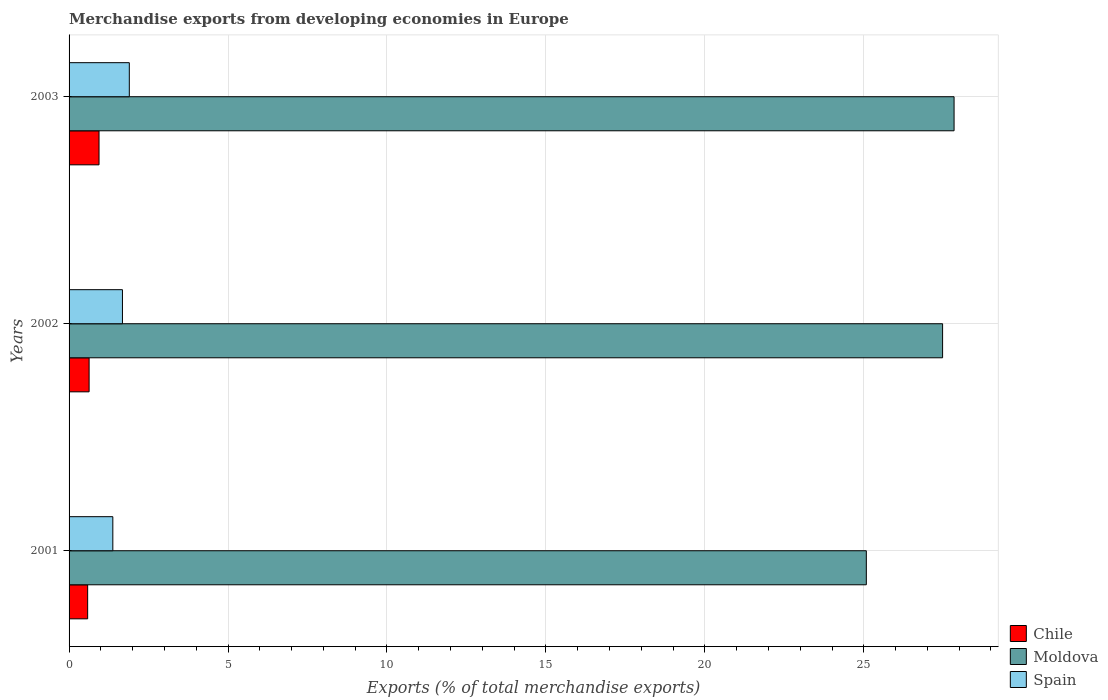How many different coloured bars are there?
Your answer should be compact. 3. How many groups of bars are there?
Offer a terse response. 3. Are the number of bars per tick equal to the number of legend labels?
Your answer should be compact. Yes. How many bars are there on the 3rd tick from the top?
Your answer should be compact. 3. How many bars are there on the 3rd tick from the bottom?
Your answer should be compact. 3. What is the label of the 1st group of bars from the top?
Your answer should be compact. 2003. What is the percentage of total merchandise exports in Chile in 2001?
Provide a succinct answer. 0.58. Across all years, what is the maximum percentage of total merchandise exports in Spain?
Offer a terse response. 1.9. Across all years, what is the minimum percentage of total merchandise exports in Chile?
Ensure brevity in your answer.  0.58. What is the total percentage of total merchandise exports in Spain in the graph?
Make the answer very short. 4.95. What is the difference between the percentage of total merchandise exports in Chile in 2001 and that in 2003?
Keep it short and to the point. -0.36. What is the difference between the percentage of total merchandise exports in Chile in 2001 and the percentage of total merchandise exports in Spain in 2003?
Offer a very short reply. -1.31. What is the average percentage of total merchandise exports in Chile per year?
Your answer should be very brief. 0.72. In the year 2001, what is the difference between the percentage of total merchandise exports in Spain and percentage of total merchandise exports in Chile?
Provide a succinct answer. 0.79. What is the ratio of the percentage of total merchandise exports in Chile in 2001 to that in 2002?
Offer a terse response. 0.93. Is the difference between the percentage of total merchandise exports in Spain in 2001 and 2002 greater than the difference between the percentage of total merchandise exports in Chile in 2001 and 2002?
Your response must be concise. No. What is the difference between the highest and the second highest percentage of total merchandise exports in Moldova?
Ensure brevity in your answer.  0.36. What is the difference between the highest and the lowest percentage of total merchandise exports in Chile?
Provide a succinct answer. 0.36. In how many years, is the percentage of total merchandise exports in Moldova greater than the average percentage of total merchandise exports in Moldova taken over all years?
Offer a very short reply. 2. Is the sum of the percentage of total merchandise exports in Chile in 2001 and 2002 greater than the maximum percentage of total merchandise exports in Spain across all years?
Provide a short and direct response. No. What does the 3rd bar from the bottom in 2002 represents?
Offer a very short reply. Spain. Is it the case that in every year, the sum of the percentage of total merchandise exports in Chile and percentage of total merchandise exports in Moldova is greater than the percentage of total merchandise exports in Spain?
Ensure brevity in your answer.  Yes. Are all the bars in the graph horizontal?
Offer a very short reply. Yes. How many years are there in the graph?
Your response must be concise. 3. What is the difference between two consecutive major ticks on the X-axis?
Provide a succinct answer. 5. Are the values on the major ticks of X-axis written in scientific E-notation?
Your answer should be very brief. No. Does the graph contain grids?
Your answer should be compact. Yes. How many legend labels are there?
Your answer should be compact. 3. What is the title of the graph?
Your answer should be compact. Merchandise exports from developing economies in Europe. What is the label or title of the X-axis?
Give a very brief answer. Exports (% of total merchandise exports). What is the label or title of the Y-axis?
Give a very brief answer. Years. What is the Exports (% of total merchandise exports) in Chile in 2001?
Make the answer very short. 0.58. What is the Exports (% of total merchandise exports) in Moldova in 2001?
Provide a short and direct response. 25.08. What is the Exports (% of total merchandise exports) of Spain in 2001?
Your answer should be compact. 1.38. What is the Exports (% of total merchandise exports) in Chile in 2002?
Provide a succinct answer. 0.63. What is the Exports (% of total merchandise exports) in Moldova in 2002?
Provide a short and direct response. 27.48. What is the Exports (% of total merchandise exports) of Spain in 2002?
Your answer should be very brief. 1.68. What is the Exports (% of total merchandise exports) in Chile in 2003?
Make the answer very short. 0.94. What is the Exports (% of total merchandise exports) of Moldova in 2003?
Keep it short and to the point. 27.84. What is the Exports (% of total merchandise exports) in Spain in 2003?
Offer a very short reply. 1.9. Across all years, what is the maximum Exports (% of total merchandise exports) of Chile?
Make the answer very short. 0.94. Across all years, what is the maximum Exports (% of total merchandise exports) in Moldova?
Your answer should be very brief. 27.84. Across all years, what is the maximum Exports (% of total merchandise exports) in Spain?
Make the answer very short. 1.9. Across all years, what is the minimum Exports (% of total merchandise exports) in Chile?
Provide a short and direct response. 0.58. Across all years, what is the minimum Exports (% of total merchandise exports) of Moldova?
Offer a very short reply. 25.08. Across all years, what is the minimum Exports (% of total merchandise exports) in Spain?
Give a very brief answer. 1.38. What is the total Exports (% of total merchandise exports) of Chile in the graph?
Provide a short and direct response. 2.16. What is the total Exports (% of total merchandise exports) in Moldova in the graph?
Make the answer very short. 80.4. What is the total Exports (% of total merchandise exports) in Spain in the graph?
Offer a terse response. 4.95. What is the difference between the Exports (% of total merchandise exports) of Chile in 2001 and that in 2002?
Your answer should be very brief. -0.05. What is the difference between the Exports (% of total merchandise exports) in Moldova in 2001 and that in 2002?
Provide a short and direct response. -2.4. What is the difference between the Exports (% of total merchandise exports) in Spain in 2001 and that in 2002?
Offer a very short reply. -0.3. What is the difference between the Exports (% of total merchandise exports) in Chile in 2001 and that in 2003?
Provide a short and direct response. -0.36. What is the difference between the Exports (% of total merchandise exports) in Moldova in 2001 and that in 2003?
Offer a very short reply. -2.76. What is the difference between the Exports (% of total merchandise exports) in Spain in 2001 and that in 2003?
Your response must be concise. -0.52. What is the difference between the Exports (% of total merchandise exports) of Chile in 2002 and that in 2003?
Provide a short and direct response. -0.31. What is the difference between the Exports (% of total merchandise exports) of Moldova in 2002 and that in 2003?
Provide a succinct answer. -0.36. What is the difference between the Exports (% of total merchandise exports) of Spain in 2002 and that in 2003?
Make the answer very short. -0.22. What is the difference between the Exports (% of total merchandise exports) in Chile in 2001 and the Exports (% of total merchandise exports) in Moldova in 2002?
Your answer should be compact. -26.89. What is the difference between the Exports (% of total merchandise exports) of Chile in 2001 and the Exports (% of total merchandise exports) of Spain in 2002?
Give a very brief answer. -1.09. What is the difference between the Exports (% of total merchandise exports) of Moldova in 2001 and the Exports (% of total merchandise exports) of Spain in 2002?
Ensure brevity in your answer.  23.4. What is the difference between the Exports (% of total merchandise exports) in Chile in 2001 and the Exports (% of total merchandise exports) in Moldova in 2003?
Keep it short and to the point. -27.25. What is the difference between the Exports (% of total merchandise exports) of Chile in 2001 and the Exports (% of total merchandise exports) of Spain in 2003?
Ensure brevity in your answer.  -1.31. What is the difference between the Exports (% of total merchandise exports) in Moldova in 2001 and the Exports (% of total merchandise exports) in Spain in 2003?
Keep it short and to the point. 23.18. What is the difference between the Exports (% of total merchandise exports) in Chile in 2002 and the Exports (% of total merchandise exports) in Moldova in 2003?
Your response must be concise. -27.21. What is the difference between the Exports (% of total merchandise exports) of Chile in 2002 and the Exports (% of total merchandise exports) of Spain in 2003?
Your answer should be very brief. -1.26. What is the difference between the Exports (% of total merchandise exports) of Moldova in 2002 and the Exports (% of total merchandise exports) of Spain in 2003?
Your answer should be very brief. 25.58. What is the average Exports (% of total merchandise exports) in Chile per year?
Offer a very short reply. 0.72. What is the average Exports (% of total merchandise exports) in Moldova per year?
Give a very brief answer. 26.8. What is the average Exports (% of total merchandise exports) of Spain per year?
Ensure brevity in your answer.  1.65. In the year 2001, what is the difference between the Exports (% of total merchandise exports) of Chile and Exports (% of total merchandise exports) of Moldova?
Your answer should be very brief. -24.49. In the year 2001, what is the difference between the Exports (% of total merchandise exports) in Chile and Exports (% of total merchandise exports) in Spain?
Keep it short and to the point. -0.79. In the year 2001, what is the difference between the Exports (% of total merchandise exports) of Moldova and Exports (% of total merchandise exports) of Spain?
Your answer should be very brief. 23.7. In the year 2002, what is the difference between the Exports (% of total merchandise exports) of Chile and Exports (% of total merchandise exports) of Moldova?
Keep it short and to the point. -26.85. In the year 2002, what is the difference between the Exports (% of total merchandise exports) of Chile and Exports (% of total merchandise exports) of Spain?
Your response must be concise. -1.05. In the year 2002, what is the difference between the Exports (% of total merchandise exports) in Moldova and Exports (% of total merchandise exports) in Spain?
Your answer should be very brief. 25.8. In the year 2003, what is the difference between the Exports (% of total merchandise exports) of Chile and Exports (% of total merchandise exports) of Moldova?
Keep it short and to the point. -26.9. In the year 2003, what is the difference between the Exports (% of total merchandise exports) in Chile and Exports (% of total merchandise exports) in Spain?
Provide a succinct answer. -0.95. In the year 2003, what is the difference between the Exports (% of total merchandise exports) in Moldova and Exports (% of total merchandise exports) in Spain?
Give a very brief answer. 25.94. What is the ratio of the Exports (% of total merchandise exports) in Chile in 2001 to that in 2002?
Provide a short and direct response. 0.93. What is the ratio of the Exports (% of total merchandise exports) in Moldova in 2001 to that in 2002?
Offer a very short reply. 0.91. What is the ratio of the Exports (% of total merchandise exports) of Spain in 2001 to that in 2002?
Make the answer very short. 0.82. What is the ratio of the Exports (% of total merchandise exports) in Chile in 2001 to that in 2003?
Your answer should be compact. 0.62. What is the ratio of the Exports (% of total merchandise exports) of Moldova in 2001 to that in 2003?
Your response must be concise. 0.9. What is the ratio of the Exports (% of total merchandise exports) of Spain in 2001 to that in 2003?
Your answer should be very brief. 0.73. What is the ratio of the Exports (% of total merchandise exports) in Chile in 2002 to that in 2003?
Ensure brevity in your answer.  0.67. What is the ratio of the Exports (% of total merchandise exports) of Spain in 2002 to that in 2003?
Provide a short and direct response. 0.89. What is the difference between the highest and the second highest Exports (% of total merchandise exports) of Chile?
Make the answer very short. 0.31. What is the difference between the highest and the second highest Exports (% of total merchandise exports) of Moldova?
Make the answer very short. 0.36. What is the difference between the highest and the second highest Exports (% of total merchandise exports) in Spain?
Offer a terse response. 0.22. What is the difference between the highest and the lowest Exports (% of total merchandise exports) in Chile?
Your response must be concise. 0.36. What is the difference between the highest and the lowest Exports (% of total merchandise exports) of Moldova?
Keep it short and to the point. 2.76. What is the difference between the highest and the lowest Exports (% of total merchandise exports) in Spain?
Give a very brief answer. 0.52. 